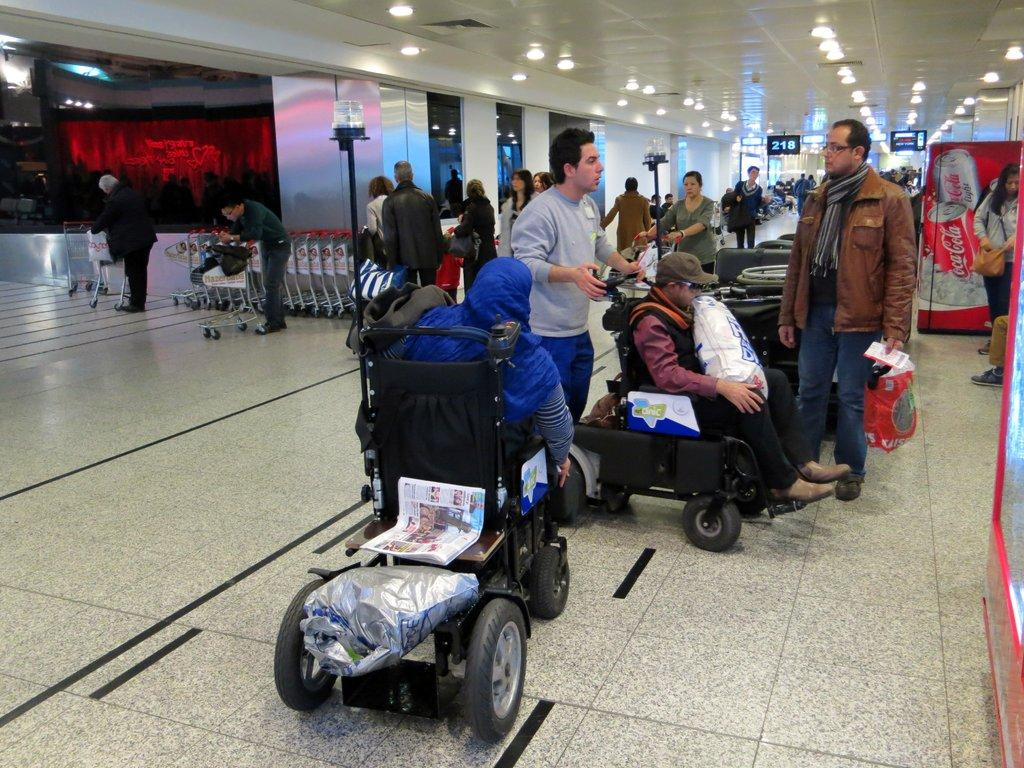<image>
Render a clear and concise summary of the photo. People in a public area and there is a coca cola machine on the right. 